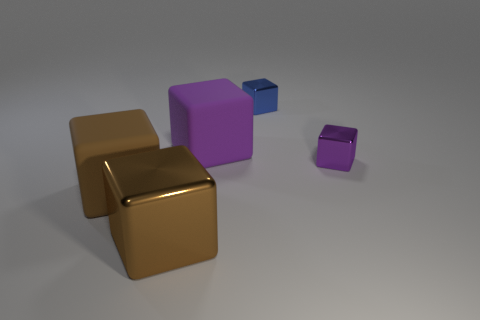What number of objects are tiny purple shiny things or things left of the large purple cube?
Provide a succinct answer. 3. What is the color of the object that is left of the tiny blue block and behind the small purple metallic cube?
Offer a terse response. Purple. Is the size of the brown matte thing the same as the brown metallic object?
Make the answer very short. Yes. What is the color of the tiny cube that is behind the tiny purple metal thing?
Your answer should be compact. Blue. Are there any blocks that have the same color as the large metal object?
Your response must be concise. Yes. What color is the other cube that is the same size as the blue cube?
Provide a short and direct response. Purple. What material is the purple thing that is on the right side of the big purple matte object?
Give a very brief answer. Metal. What color is the large metal block?
Make the answer very short. Brown. There is a brown object behind the big metallic cube; is it the same size as the metal thing on the left side of the large purple rubber block?
Provide a succinct answer. Yes. What size is the object that is in front of the tiny blue cube and behind the tiny purple cube?
Ensure brevity in your answer.  Large. 